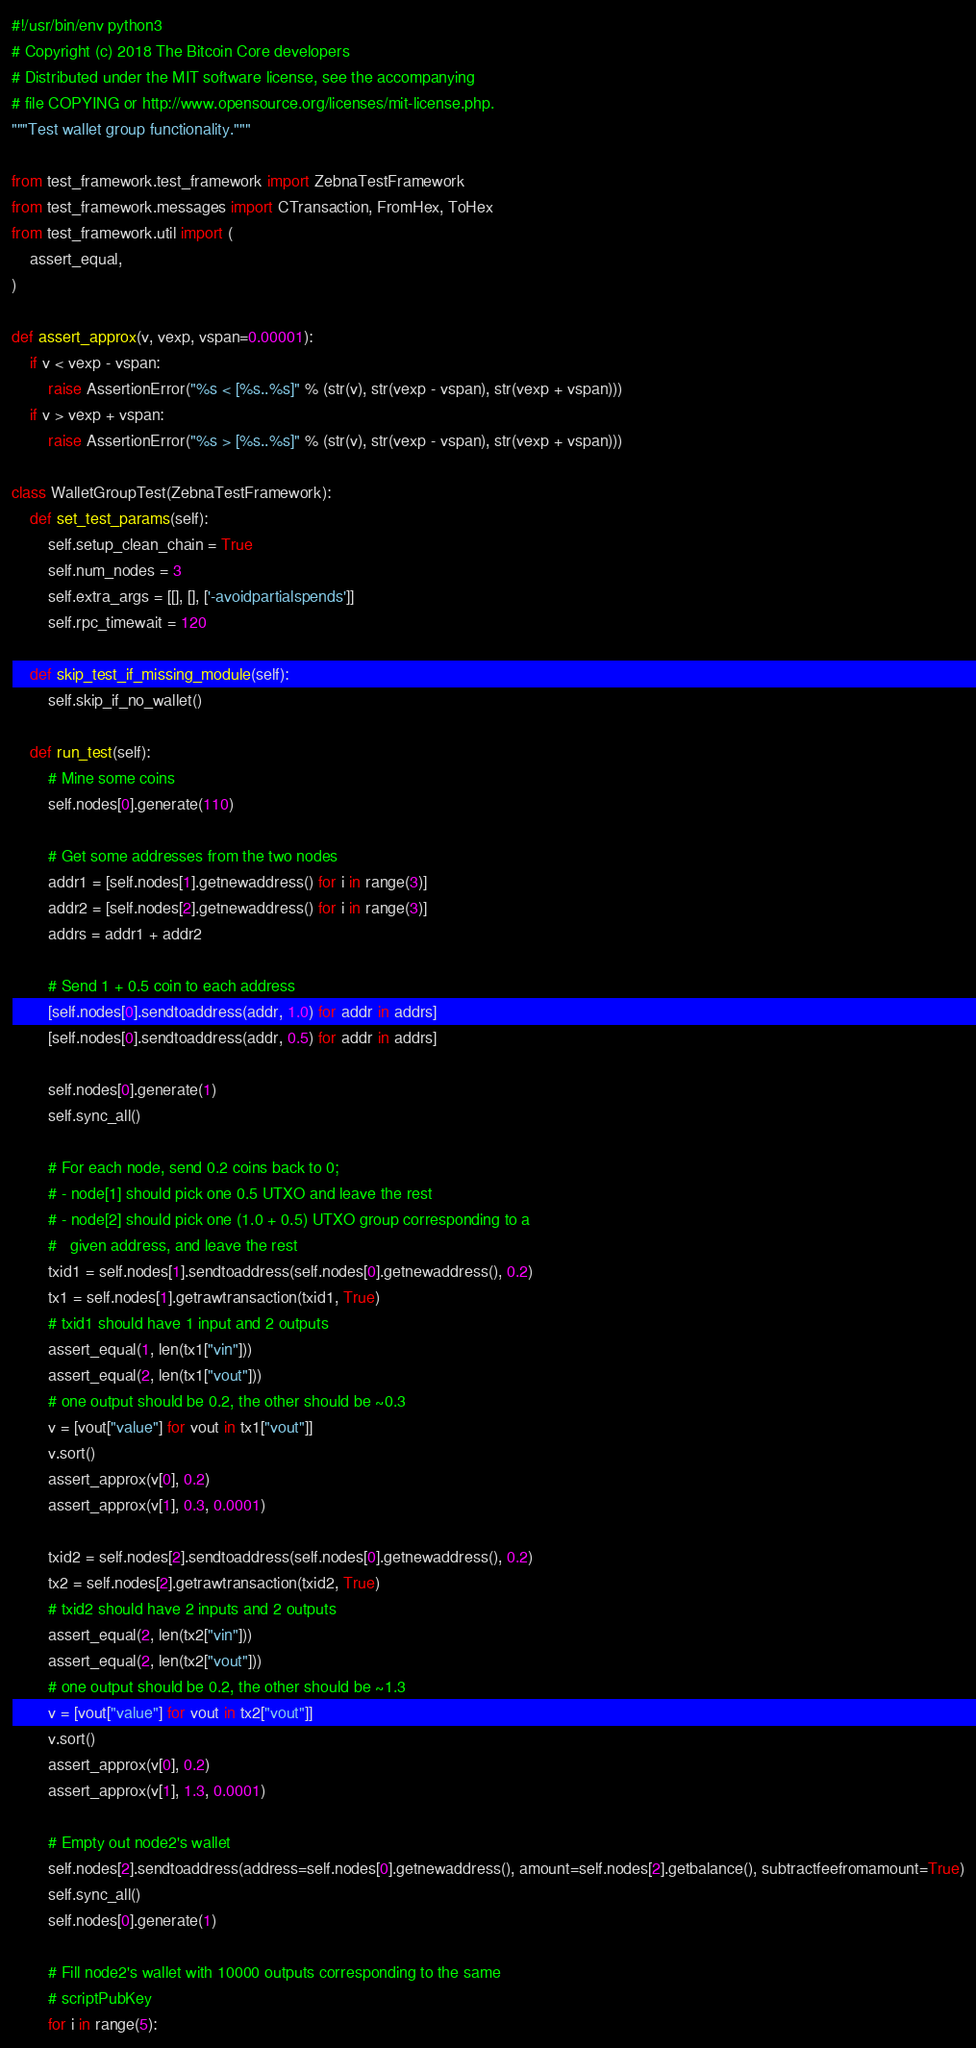Convert code to text. <code><loc_0><loc_0><loc_500><loc_500><_Python_>#!/usr/bin/env python3
# Copyright (c) 2018 The Bitcoin Core developers
# Distributed under the MIT software license, see the accompanying
# file COPYING or http://www.opensource.org/licenses/mit-license.php.
"""Test wallet group functionality."""

from test_framework.test_framework import ZebnaTestFramework
from test_framework.messages import CTransaction, FromHex, ToHex
from test_framework.util import (
    assert_equal,
)

def assert_approx(v, vexp, vspan=0.00001):
    if v < vexp - vspan:
        raise AssertionError("%s < [%s..%s]" % (str(v), str(vexp - vspan), str(vexp + vspan)))
    if v > vexp + vspan:
        raise AssertionError("%s > [%s..%s]" % (str(v), str(vexp - vspan), str(vexp + vspan)))

class WalletGroupTest(ZebnaTestFramework):
    def set_test_params(self):
        self.setup_clean_chain = True
        self.num_nodes = 3
        self.extra_args = [[], [], ['-avoidpartialspends']]
        self.rpc_timewait = 120

    def skip_test_if_missing_module(self):
        self.skip_if_no_wallet()

    def run_test(self):
        # Mine some coins
        self.nodes[0].generate(110)

        # Get some addresses from the two nodes
        addr1 = [self.nodes[1].getnewaddress() for i in range(3)]
        addr2 = [self.nodes[2].getnewaddress() for i in range(3)]
        addrs = addr1 + addr2

        # Send 1 + 0.5 coin to each address
        [self.nodes[0].sendtoaddress(addr, 1.0) for addr in addrs]
        [self.nodes[0].sendtoaddress(addr, 0.5) for addr in addrs]

        self.nodes[0].generate(1)
        self.sync_all()

        # For each node, send 0.2 coins back to 0;
        # - node[1] should pick one 0.5 UTXO and leave the rest
        # - node[2] should pick one (1.0 + 0.5) UTXO group corresponding to a
        #   given address, and leave the rest
        txid1 = self.nodes[1].sendtoaddress(self.nodes[0].getnewaddress(), 0.2)
        tx1 = self.nodes[1].getrawtransaction(txid1, True)
        # txid1 should have 1 input and 2 outputs
        assert_equal(1, len(tx1["vin"]))
        assert_equal(2, len(tx1["vout"]))
        # one output should be 0.2, the other should be ~0.3
        v = [vout["value"] for vout in tx1["vout"]]
        v.sort()
        assert_approx(v[0], 0.2)
        assert_approx(v[1], 0.3, 0.0001)

        txid2 = self.nodes[2].sendtoaddress(self.nodes[0].getnewaddress(), 0.2)
        tx2 = self.nodes[2].getrawtransaction(txid2, True)
        # txid2 should have 2 inputs and 2 outputs
        assert_equal(2, len(tx2["vin"]))
        assert_equal(2, len(tx2["vout"]))
        # one output should be 0.2, the other should be ~1.3
        v = [vout["value"] for vout in tx2["vout"]]
        v.sort()
        assert_approx(v[0], 0.2)
        assert_approx(v[1], 1.3, 0.0001)

        # Empty out node2's wallet
        self.nodes[2].sendtoaddress(address=self.nodes[0].getnewaddress(), amount=self.nodes[2].getbalance(), subtractfeefromamount=True)
        self.sync_all()
        self.nodes[0].generate(1)

        # Fill node2's wallet with 10000 outputs corresponding to the same
        # scriptPubKey
        for i in range(5):</code> 